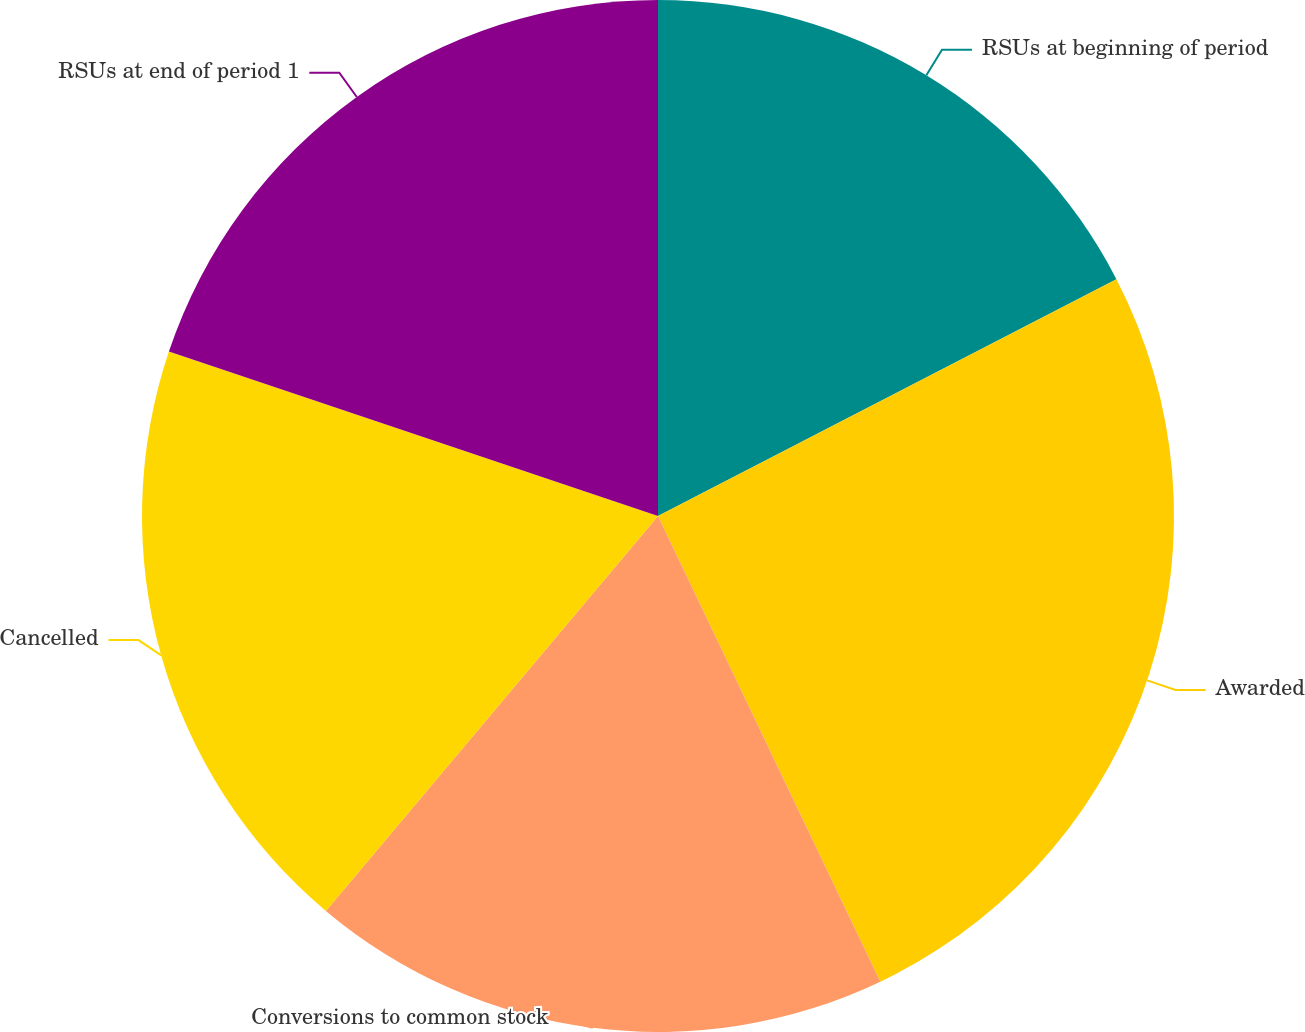Convert chart. <chart><loc_0><loc_0><loc_500><loc_500><pie_chart><fcel>RSUs at beginning of period<fcel>Awarded<fcel>Conversions to common stock<fcel>Cancelled<fcel>RSUs at end of period 1<nl><fcel>17.41%<fcel>25.5%<fcel>18.22%<fcel>19.03%<fcel>19.84%<nl></chart> 